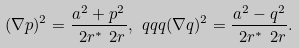Convert formula to latex. <formula><loc_0><loc_0><loc_500><loc_500>( \nabla p ) ^ { 2 } = \frac { a ^ { 2 } + p ^ { 2 } } { \ 2 r ^ { * } \ 2 r } , \ q q q ( \nabla q ) ^ { 2 } = \frac { a ^ { 2 } - q ^ { 2 } } { \ 2 r ^ { * } \ 2 r } .</formula> 